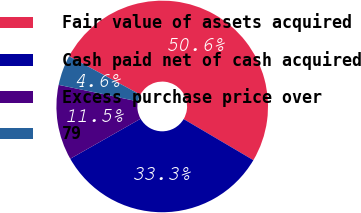Convert chart to OTSL. <chart><loc_0><loc_0><loc_500><loc_500><pie_chart><fcel>Fair value of assets acquired<fcel>Cash paid net of cash acquired<fcel>Excess purchase price over<fcel>79<nl><fcel>50.61%<fcel>33.29%<fcel>11.5%<fcel>4.59%<nl></chart> 